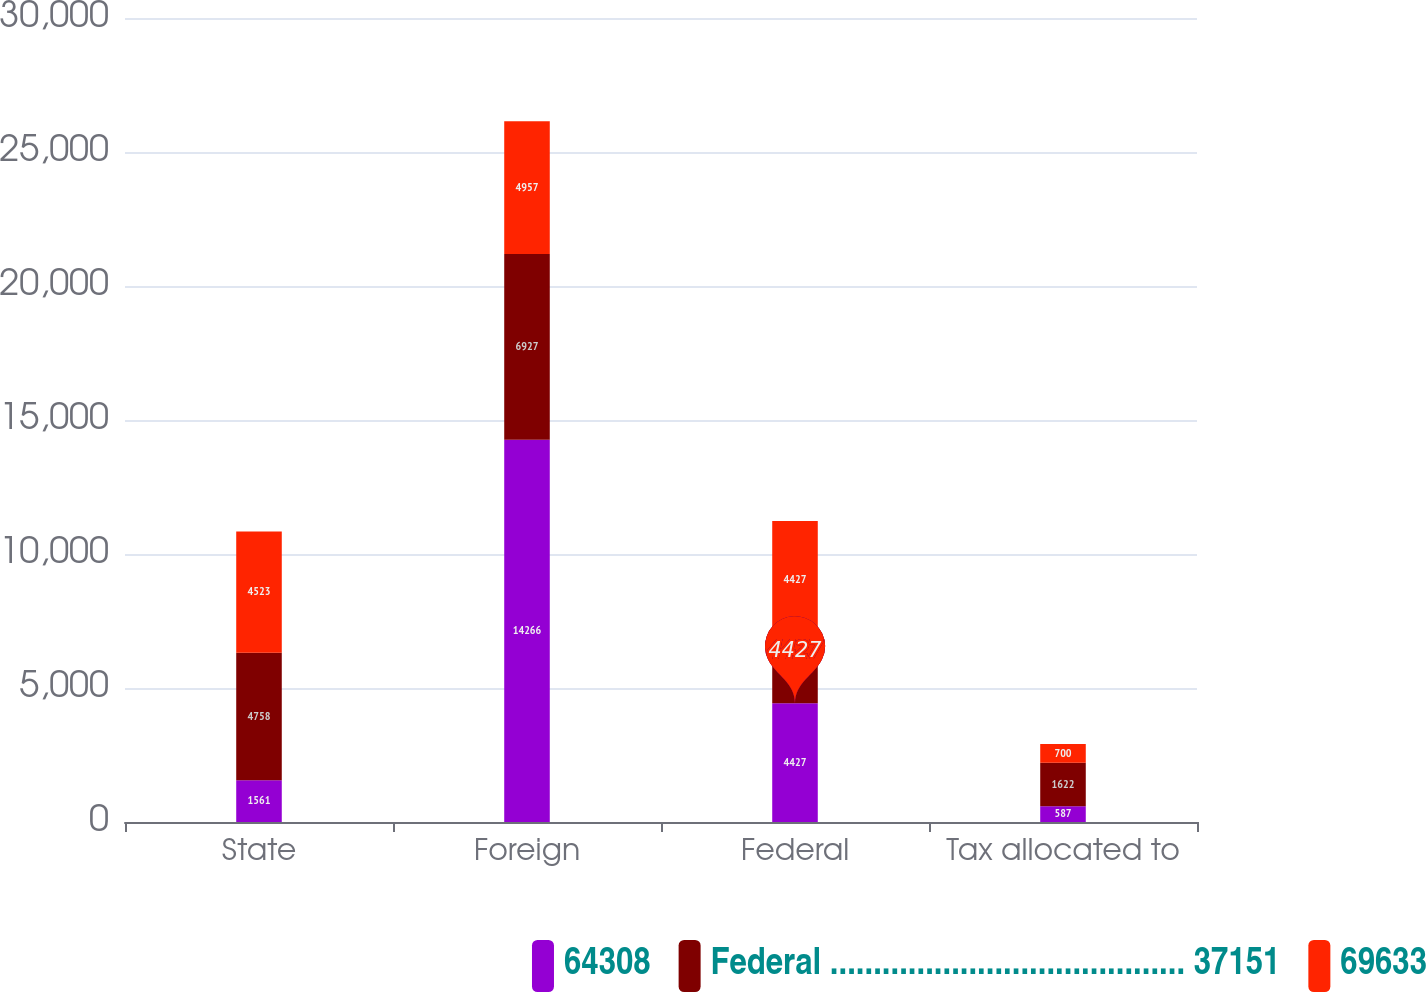Convert chart to OTSL. <chart><loc_0><loc_0><loc_500><loc_500><stacked_bar_chart><ecel><fcel>State<fcel>Foreign<fcel>Federal<fcel>Tax allocated to<nl><fcel>64308<fcel>1561<fcel>14266<fcel>4427<fcel>587<nl><fcel>Federal ......................................... 37151<fcel>4758<fcel>6927<fcel>2381<fcel>1622<nl><fcel>69633<fcel>4523<fcel>4957<fcel>4427<fcel>700<nl></chart> 